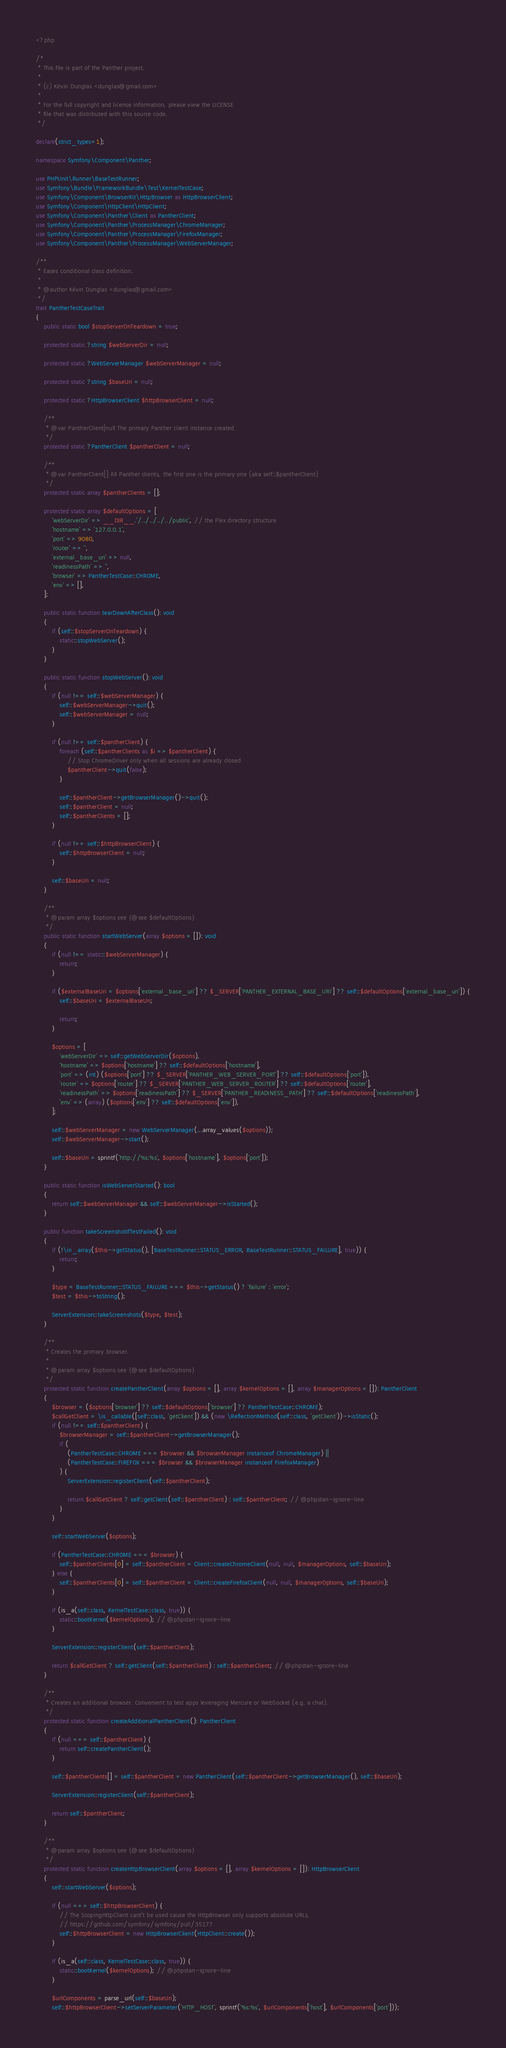Convert code to text. <code><loc_0><loc_0><loc_500><loc_500><_PHP_><?php

/*
 * This file is part of the Panther project.
 *
 * (c) Kévin Dunglas <dunglas@gmail.com>
 *
 * For the full copyright and license information, please view the LICENSE
 * file that was distributed with this source code.
 */

declare(strict_types=1);

namespace Symfony\Component\Panther;

use PHPUnit\Runner\BaseTestRunner;
use Symfony\Bundle\FrameworkBundle\Test\KernelTestCase;
use Symfony\Component\BrowserKit\HttpBrowser as HttpBrowserClient;
use Symfony\Component\HttpClient\HttpClient;
use Symfony\Component\Panther\Client as PantherClient;
use Symfony\Component\Panther\ProcessManager\ChromeManager;
use Symfony\Component\Panther\ProcessManager\FirefoxManager;
use Symfony\Component\Panther\ProcessManager\WebServerManager;

/**
 * Eases conditional class definition.
 *
 * @author Kévin Dunglas <dunglas@gmail.com>
 */
trait PantherTestCaseTrait
{
    public static bool $stopServerOnTeardown = true;

    protected static ?string $webServerDir = null;

    protected static ?WebServerManager $webServerManager = null;

    protected static ?string $baseUri = null;

    protected static ?HttpBrowserClient $httpBrowserClient = null;

    /**
     * @var PantherClient|null The primary Panther client instance created
     */
    protected static ?PantherClient $pantherClient = null;

    /**
     * @var PantherClient[] All Panther clients, the first one is the primary one (aka self::$pantherClient)
     */
    protected static array $pantherClients = [];

    protected static array $defaultOptions = [
        'webServerDir' => __DIR__.'/../../../../public', // the Flex directory structure
        'hostname' => '127.0.0.1',
        'port' => 9080,
        'router' => '',
        'external_base_uri' => null,
        'readinessPath' => '',
        'browser' => PantherTestCase::CHROME,
        'env' => [],
    ];

    public static function tearDownAfterClass(): void
    {
        if (self::$stopServerOnTeardown) {
            static::stopWebServer();
        }
    }

    public static function stopWebServer(): void
    {
        if (null !== self::$webServerManager) {
            self::$webServerManager->quit();
            self::$webServerManager = null;
        }

        if (null !== self::$pantherClient) {
            foreach (self::$pantherClients as $i => $pantherClient) {
                // Stop ChromeDriver only when all sessions are already closed
                $pantherClient->quit(false);
            }

            self::$pantherClient->getBrowserManager()->quit();
            self::$pantherClient = null;
            self::$pantherClients = [];
        }

        if (null !== self::$httpBrowserClient) {
            self::$httpBrowserClient = null;
        }

        self::$baseUri = null;
    }

    /**
     * @param array $options see {@see $defaultOptions}
     */
    public static function startWebServer(array $options = []): void
    {
        if (null !== static::$webServerManager) {
            return;
        }

        if ($externalBaseUri = $options['external_base_uri'] ?? $_SERVER['PANTHER_EXTERNAL_BASE_URI'] ?? self::$defaultOptions['external_base_uri']) {
            self::$baseUri = $externalBaseUri;

            return;
        }

        $options = [
            'webServerDir' => self::getWebServerDir($options),
            'hostname' => $options['hostname'] ?? self::$defaultOptions['hostname'],
            'port' => (int) ($options['port'] ?? $_SERVER['PANTHER_WEB_SERVER_PORT'] ?? self::$defaultOptions['port']),
            'router' => $options['router'] ?? $_SERVER['PANTHER_WEB_SERVER_ROUTER'] ?? self::$defaultOptions['router'],
            'readinessPath' => $options['readinessPath'] ?? $_SERVER['PANTHER_READINESS_PATH'] ?? self::$defaultOptions['readinessPath'],
            'env' => (array) ($options['env'] ?? self::$defaultOptions['env']),
        ];

        self::$webServerManager = new WebServerManager(...array_values($options));
        self::$webServerManager->start();

        self::$baseUri = sprintf('http://%s:%s', $options['hostname'], $options['port']);
    }

    public static function isWebServerStarted(): bool
    {
        return self::$webServerManager && self::$webServerManager->isStarted();
    }

    public function takeScreenshotIfTestFailed(): void
    {
        if (!\in_array($this->getStatus(), [BaseTestRunner::STATUS_ERROR, BaseTestRunner::STATUS_FAILURE], true)) {
            return;
        }

        $type = BaseTestRunner::STATUS_FAILURE === $this->getStatus() ? 'failure' : 'error';
        $test = $this->toString();

        ServerExtension::takeScreenshots($type, $test);
    }

    /**
     * Creates the primary browser.
     *
     * @param array $options see {@see $defaultOptions}
     */
    protected static function createPantherClient(array $options = [], array $kernelOptions = [], array $managerOptions = []): PantherClient
    {
        $browser = ($options['browser'] ?? self::$defaultOptions['browser'] ?? PantherTestCase::CHROME);
        $callGetClient = \is_callable([self::class, 'getClient']) && (new \ReflectionMethod(self::class, 'getClient'))->isStatic();
        if (null !== self::$pantherClient) {
            $browserManager = self::$pantherClient->getBrowserManager();
            if (
                (PantherTestCase::CHROME === $browser && $browserManager instanceof ChromeManager) ||
                (PantherTestCase::FIREFOX === $browser && $browserManager instanceof FirefoxManager)
            ) {
                ServerExtension::registerClient(self::$pantherClient);

                return $callGetClient ? self::getClient(self::$pantherClient) : self::$pantherClient; // @phpstan-ignore-line
            }
        }

        self::startWebServer($options);

        if (PantherTestCase::CHROME === $browser) {
            self::$pantherClients[0] = self::$pantherClient = Client::createChromeClient(null, null, $managerOptions, self::$baseUri);
        } else {
            self::$pantherClients[0] = self::$pantherClient = Client::createFirefoxClient(null, null, $managerOptions, self::$baseUri);
        }

        if (is_a(self::class, KernelTestCase::class, true)) {
            static::bootKernel($kernelOptions); // @phpstan-ignore-line
        }

        ServerExtension::registerClient(self::$pantherClient);

        return $callGetClient ? self::getClient(self::$pantherClient) : self::$pantherClient; // @phpstan-ignore-line
    }

    /**
     * Creates an additional browser. Convenient to test apps leveraging Mercure or WebSocket (e.g. a chat).
     */
    protected static function createAdditionalPantherClient(): PantherClient
    {
        if (null === self::$pantherClient) {
            return self::createPantherClient();
        }

        self::$pantherClients[] = self::$pantherClient = new PantherClient(self::$pantherClient->getBrowserManager(), self::$baseUri);

        ServerExtension::registerClient(self::$pantherClient);

        return self::$pantherClient;
    }

    /**
     * @param array $options see {@see $defaultOptions}
     */
    protected static function createHttpBrowserClient(array $options = [], array $kernelOptions = []): HttpBrowserClient
    {
        self::startWebServer($options);

        if (null === self::$httpBrowserClient) {
            // The ScopingHttpClient cant't be used cause the HttpBrowser only supports absolute URLs,
            // https://github.com/symfony/symfony/pull/35177
            self::$httpBrowserClient = new HttpBrowserClient(HttpClient::create());
        }

        if (is_a(self::class, KernelTestCase::class, true)) {
            static::bootKernel($kernelOptions); // @phpstan-ignore-line
        }

        $urlComponents = parse_url(self::$baseUri);
        self::$httpBrowserClient->setServerParameter('HTTP_HOST', sprintf('%s:%s', $urlComponents['host'], $urlComponents['port']));</code> 